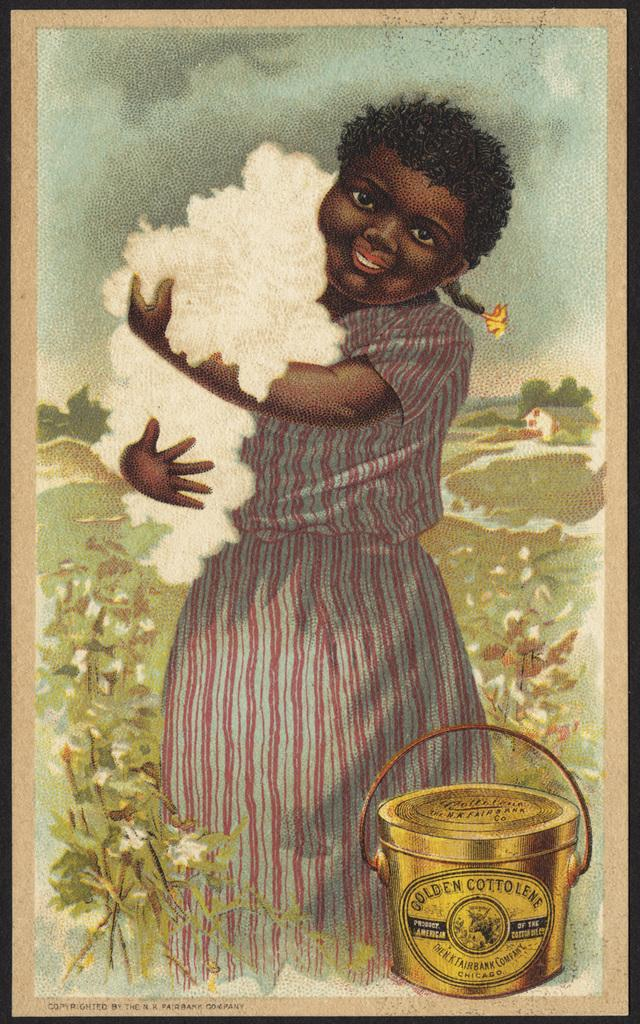<image>
Summarize the visual content of the image. A woman holding cotton is used in an advertisement for Golden Cottolene. 